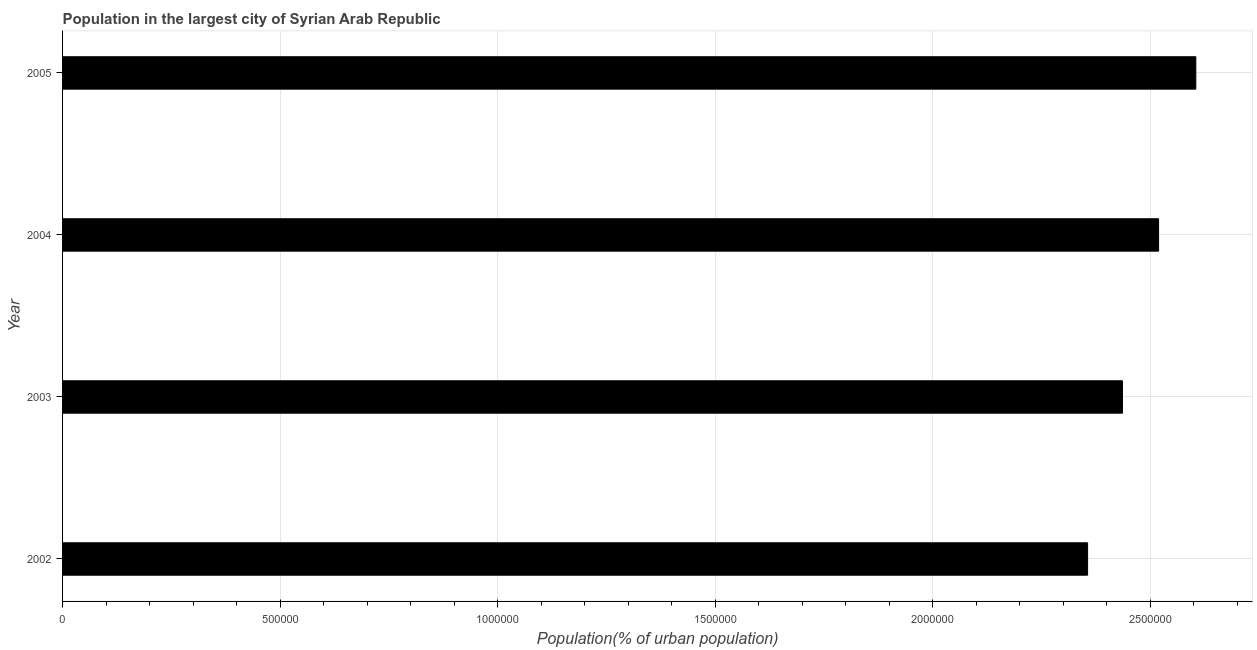Does the graph contain any zero values?
Your answer should be compact. No. What is the title of the graph?
Offer a very short reply. Population in the largest city of Syrian Arab Republic. What is the label or title of the X-axis?
Give a very brief answer. Population(% of urban population). What is the population in largest city in 2004?
Give a very brief answer. 2.52e+06. Across all years, what is the maximum population in largest city?
Provide a short and direct response. 2.60e+06. Across all years, what is the minimum population in largest city?
Your response must be concise. 2.36e+06. In which year was the population in largest city maximum?
Your response must be concise. 2005. In which year was the population in largest city minimum?
Offer a very short reply. 2002. What is the sum of the population in largest city?
Your response must be concise. 9.92e+06. What is the difference between the population in largest city in 2003 and 2004?
Your answer should be compact. -8.30e+04. What is the average population in largest city per year?
Your answer should be compact. 2.48e+06. What is the median population in largest city?
Make the answer very short. 2.48e+06. Do a majority of the years between 2002 and 2004 (inclusive) have population in largest city greater than 1800000 %?
Provide a short and direct response. Yes. What is the ratio of the population in largest city in 2003 to that in 2005?
Make the answer very short. 0.94. What is the difference between the highest and the second highest population in largest city?
Provide a short and direct response. 8.56e+04. What is the difference between the highest and the lowest population in largest city?
Provide a short and direct response. 2.49e+05. How many bars are there?
Keep it short and to the point. 4. Are all the bars in the graph horizontal?
Your response must be concise. Yes. How many years are there in the graph?
Give a very brief answer. 4. Are the values on the major ticks of X-axis written in scientific E-notation?
Give a very brief answer. No. What is the Population(% of urban population) of 2002?
Your response must be concise. 2.36e+06. What is the Population(% of urban population) in 2003?
Offer a terse response. 2.44e+06. What is the Population(% of urban population) of 2004?
Ensure brevity in your answer.  2.52e+06. What is the Population(% of urban population) of 2005?
Make the answer very short. 2.60e+06. What is the difference between the Population(% of urban population) in 2002 and 2003?
Provide a short and direct response. -8.02e+04. What is the difference between the Population(% of urban population) in 2002 and 2004?
Provide a succinct answer. -1.63e+05. What is the difference between the Population(% of urban population) in 2002 and 2005?
Keep it short and to the point. -2.49e+05. What is the difference between the Population(% of urban population) in 2003 and 2004?
Your answer should be very brief. -8.30e+04. What is the difference between the Population(% of urban population) in 2003 and 2005?
Give a very brief answer. -1.69e+05. What is the difference between the Population(% of urban population) in 2004 and 2005?
Offer a terse response. -8.56e+04. What is the ratio of the Population(% of urban population) in 2002 to that in 2003?
Give a very brief answer. 0.97. What is the ratio of the Population(% of urban population) in 2002 to that in 2004?
Keep it short and to the point. 0.94. What is the ratio of the Population(% of urban population) in 2002 to that in 2005?
Offer a terse response. 0.9. What is the ratio of the Population(% of urban population) in 2003 to that in 2005?
Keep it short and to the point. 0.94. 